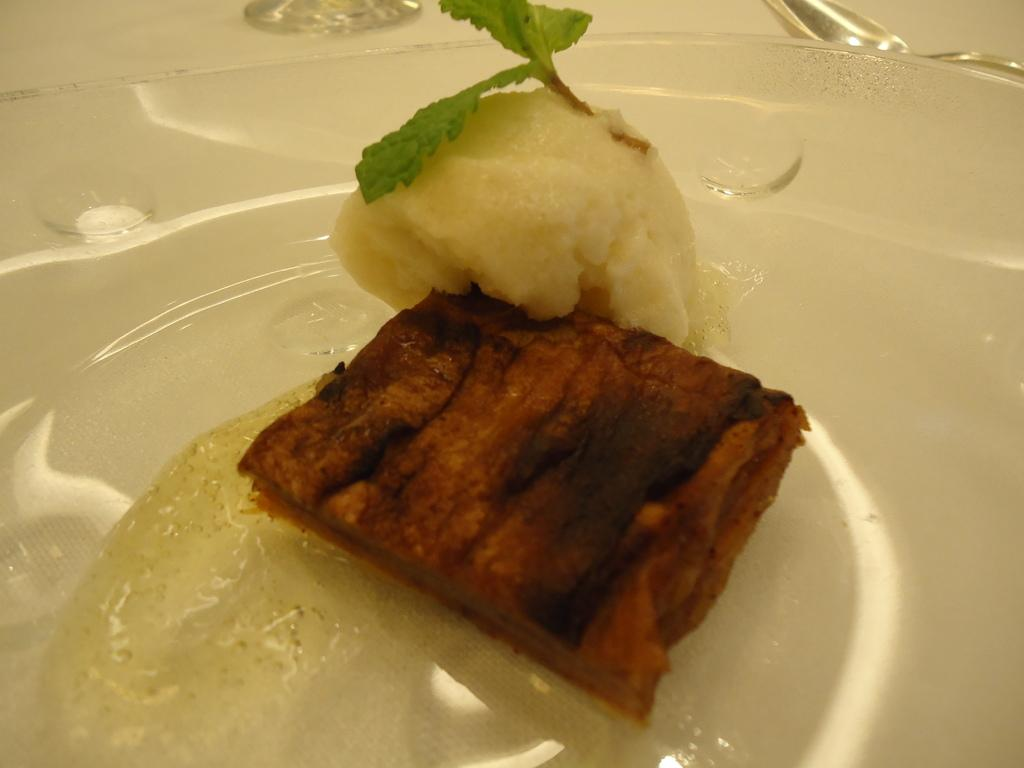What is on the plate in the image? There is a plate with food in the image. What utensil is visible on the right side of the image? There is a spoon visible on the right side of the image. What can be seen in the background of the image? There is a glass in the background of the image. What color is the background in the image? The background has a white color. Can you see a cap on the plate in the image? No, there is no cap present on the plate in the image. 